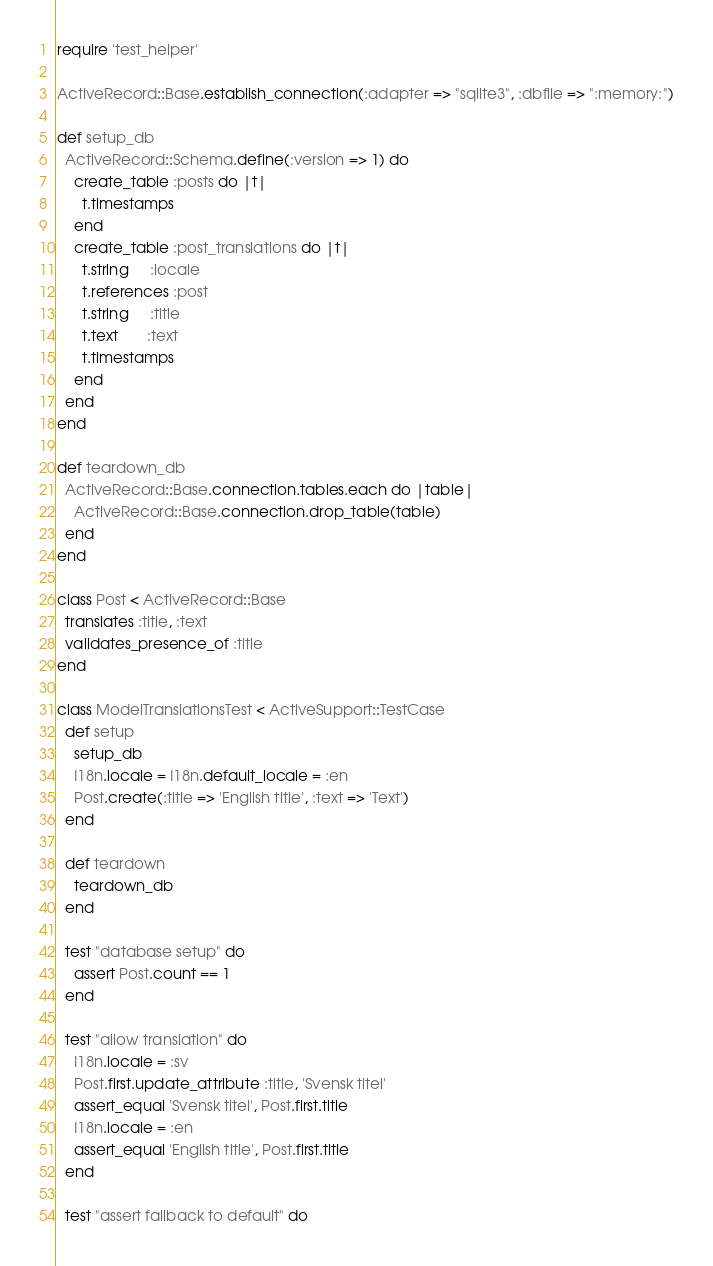Convert code to text. <code><loc_0><loc_0><loc_500><loc_500><_Ruby_>require 'test_helper'

ActiveRecord::Base.establish_connection(:adapter => "sqlite3", :dbfile => ":memory:")

def setup_db
  ActiveRecord::Schema.define(:version => 1) do
    create_table :posts do |t|
      t.timestamps
    end
    create_table :post_translations do |t|
      t.string     :locale
      t.references :post
      t.string     :title
      t.text       :text
      t.timestamps
    end
  end
end

def teardown_db
  ActiveRecord::Base.connection.tables.each do |table|
    ActiveRecord::Base.connection.drop_table(table)
  end
end

class Post < ActiveRecord::Base
  translates :title, :text
  validates_presence_of :title
end

class ModelTranslationsTest < ActiveSupport::TestCase
  def setup
    setup_db
    I18n.locale = I18n.default_locale = :en
    Post.create(:title => 'English title', :text => 'Text')
  end

  def teardown
    teardown_db
  end

  test "database setup" do
    assert Post.count == 1
  end

  test "allow translation" do
    I18n.locale = :sv
    Post.first.update_attribute :title, 'Svensk titel'
    assert_equal 'Svensk titel', Post.first.title
    I18n.locale = :en
    assert_equal 'English title', Post.first.title
  end

  test "assert fallback to default" do</code> 